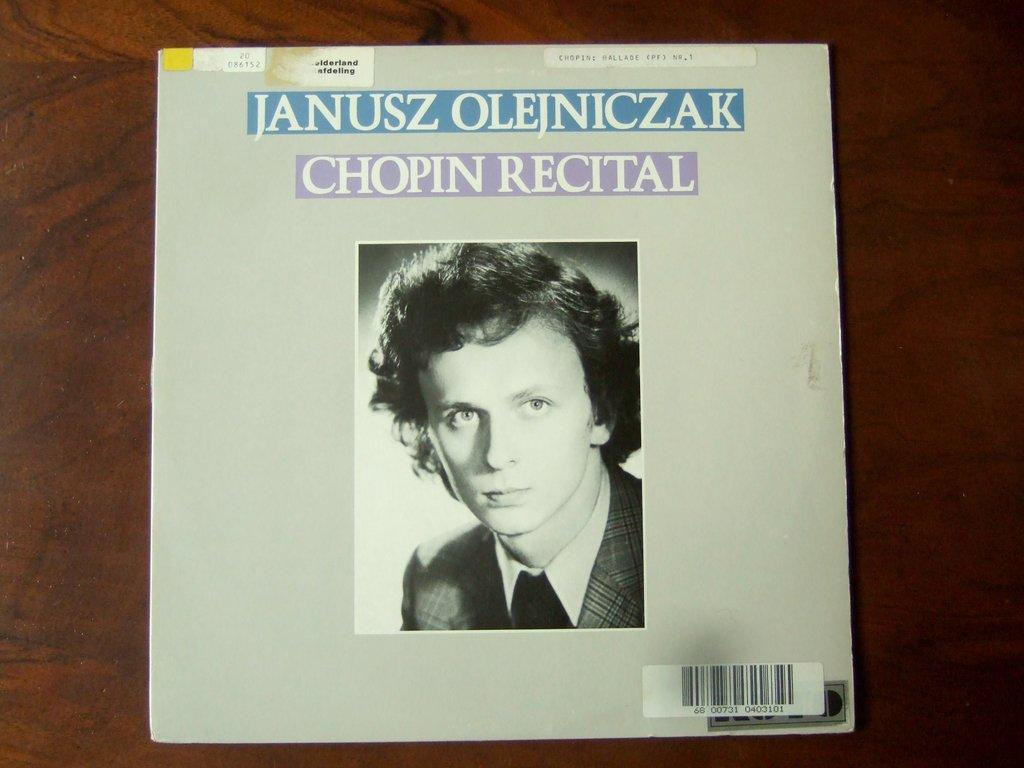What is featured on the poster in the image? The poster has a person on it. What else can be seen on the poster besides the person? There is text on the poster. What type of surface is the poster placed on? The poster is on a wooden surface. What type of tin can be seen in the image? There is no tin present in the image. Can you tell me how many parents are depicted on the poster? The poster only features a single person, so there are no parents depicted. 